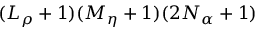<formula> <loc_0><loc_0><loc_500><loc_500>( L _ { \rho } + 1 ) ( M _ { \eta } + 1 ) ( 2 N _ { \alpha } + 1 )</formula> 